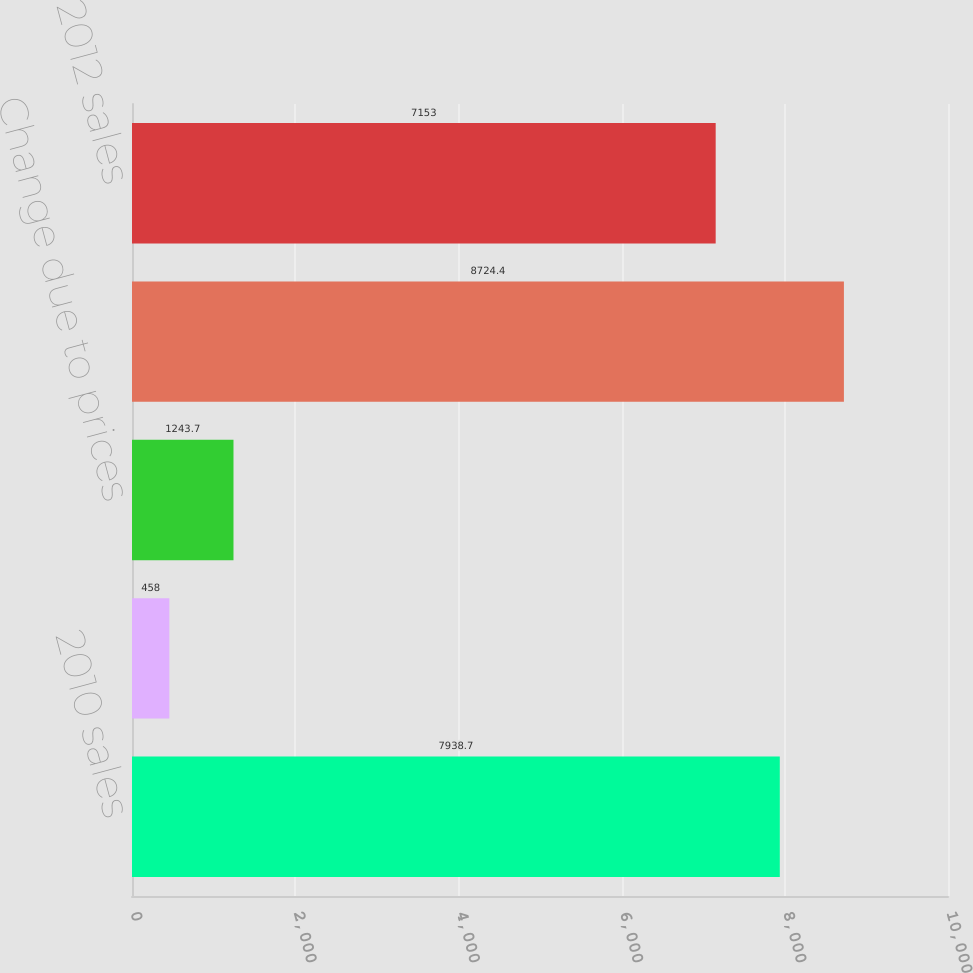<chart> <loc_0><loc_0><loc_500><loc_500><bar_chart><fcel>2010 sales<fcel>Change due to volumes<fcel>Change due to prices<fcel>2011 sales<fcel>2012 sales<nl><fcel>7938.7<fcel>458<fcel>1243.7<fcel>8724.4<fcel>7153<nl></chart> 